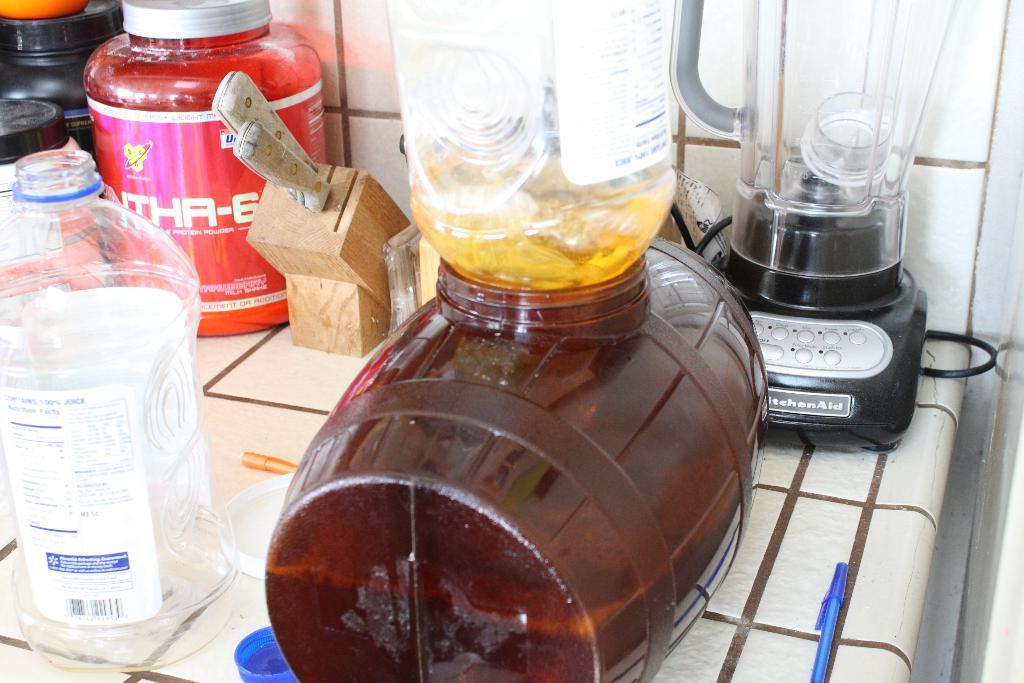Provide a one-sentence caption for the provided image. A number of appliances on a kitchen counter in front of a Kitchenaid blender. 